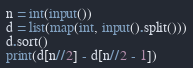Convert code to text. <code><loc_0><loc_0><loc_500><loc_500><_Python_>n = int(input())
d = list(map(int, input().split()))
d.sort()
print(d[n//2] - d[n//2 - 1])</code> 